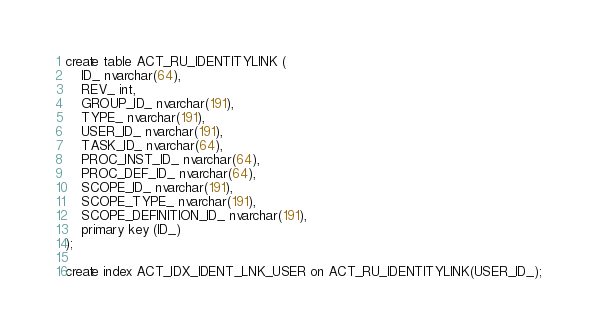Convert code to text. <code><loc_0><loc_0><loc_500><loc_500><_SQL_>create table ACT_RU_IDENTITYLINK (
    ID_ nvarchar(64),
    REV_ int,
    GROUP_ID_ nvarchar(191),
    TYPE_ nvarchar(191),
    USER_ID_ nvarchar(191),
    TASK_ID_ nvarchar(64),
    PROC_INST_ID_ nvarchar(64),
    PROC_DEF_ID_ nvarchar(64),
    SCOPE_ID_ nvarchar(191),
    SCOPE_TYPE_ nvarchar(191),
    SCOPE_DEFINITION_ID_ nvarchar(191),
    primary key (ID_)
);

create index ACT_IDX_IDENT_LNK_USER on ACT_RU_IDENTITYLINK(USER_ID_);</code> 